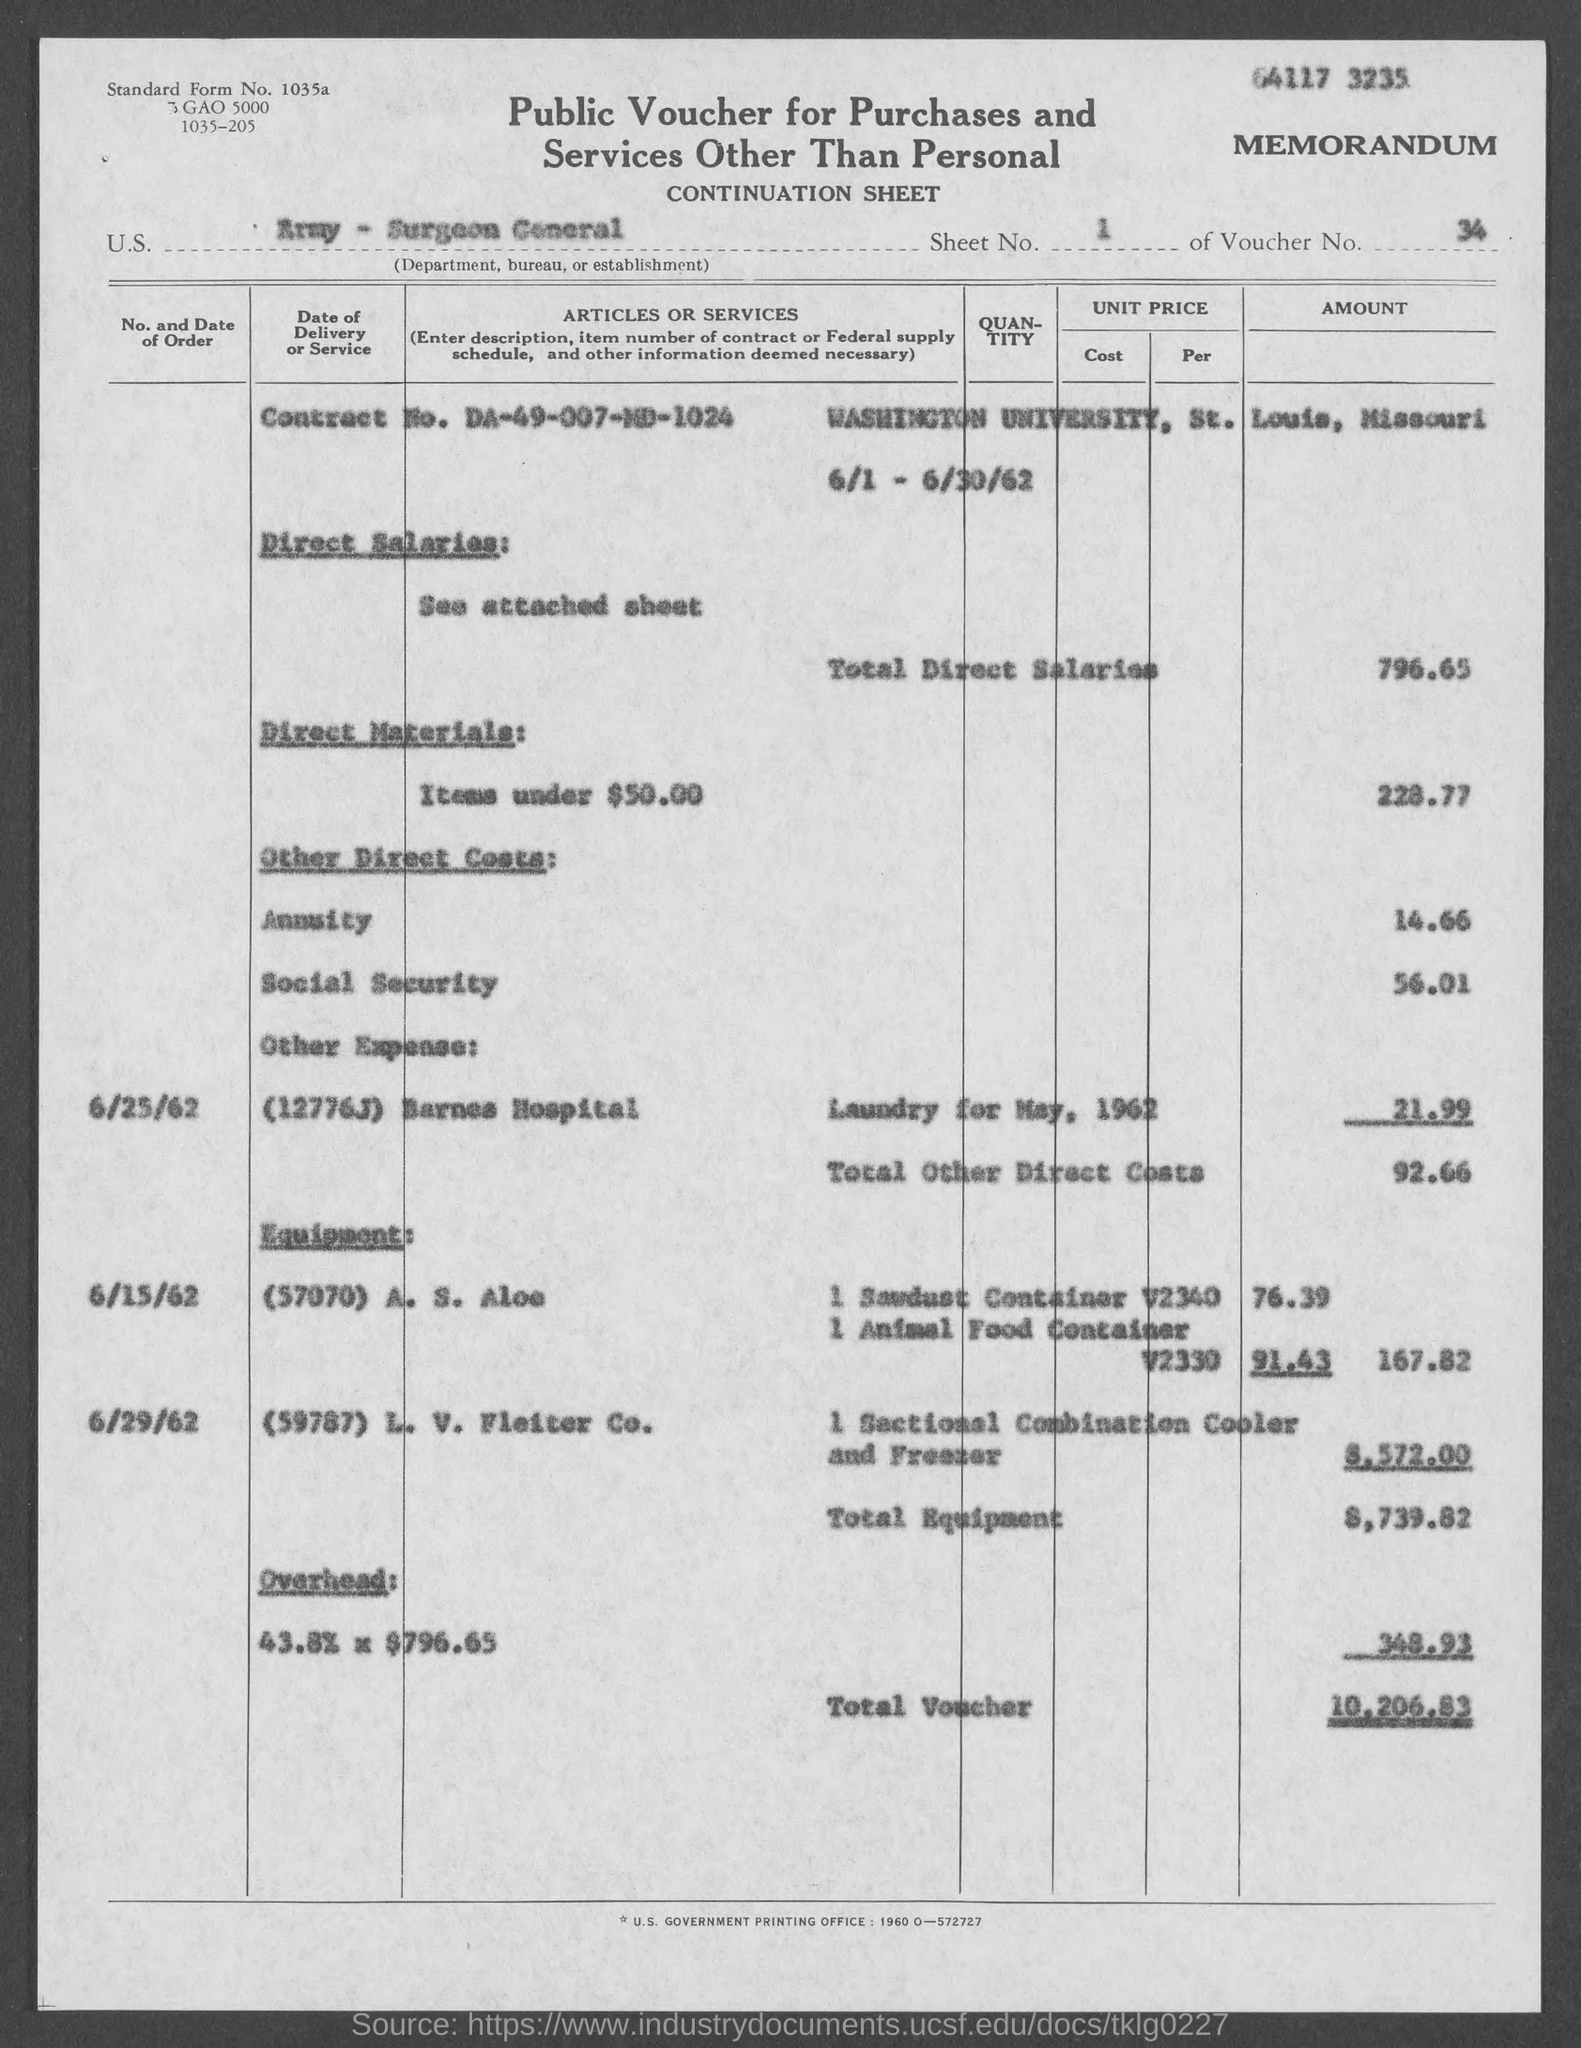What is the sheet no.?
Provide a short and direct response. 1. What is the voucher no.?
Offer a terse response. 34. What is the standard form no.?
Offer a terse response. 1035a. What is the contract no.?
Provide a short and direct response. DA-49-007-MD-1024. What is the total voucher amount ?
Provide a succinct answer. 10,206.83. What is the total direct salaries ?
Provide a short and direct response. 796.65. What is the total other direct costs?
Offer a very short reply. 92.66. What is the total equipment amount ?
Make the answer very short. $8,739.82. 